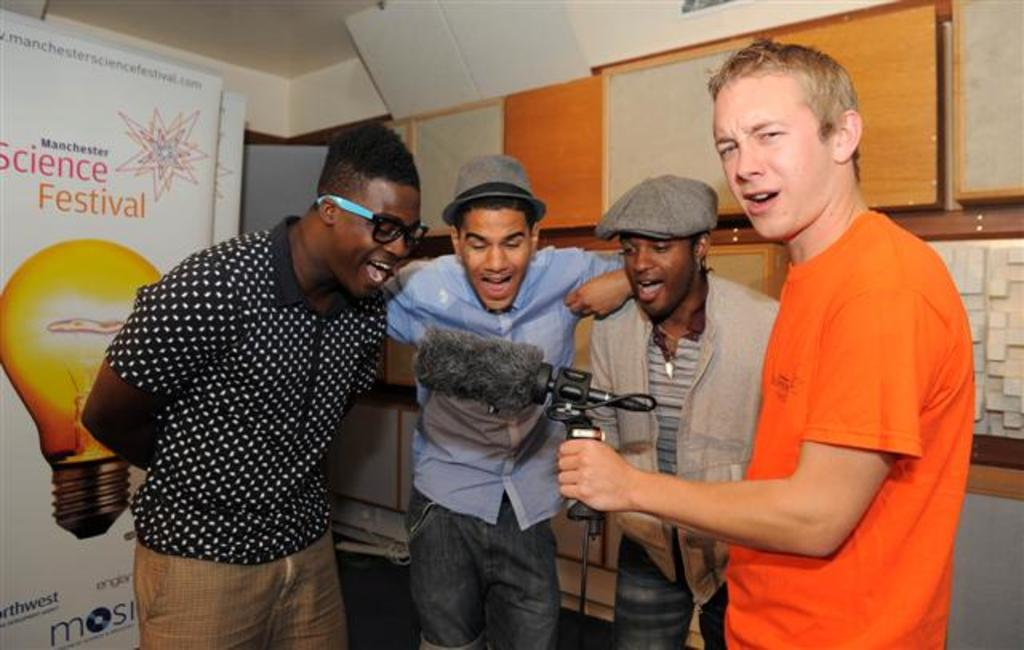What is happening in the image? There are people standing in the image. Can you describe what one of the people is holding? A man is holding an item in his hand. Are there any accessories that some people are wearing? Some people are wearing caps in the image. What can be seen in the background of the image? There is a hoarding visible in the image. What type of lock can be seen on the cellar door in the image? There is no cellar door or lock present in the image. 